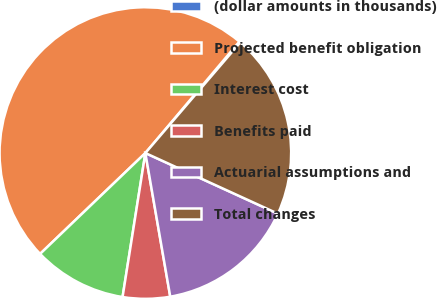<chart> <loc_0><loc_0><loc_500><loc_500><pie_chart><fcel>(dollar amounts in thousands)<fcel>Projected benefit obligation<fcel>Interest cost<fcel>Benefits paid<fcel>Actuarial assumptions and<fcel>Total changes<nl><fcel>0.13%<fcel>48.31%<fcel>10.34%<fcel>5.23%<fcel>15.44%<fcel>20.55%<nl></chart> 